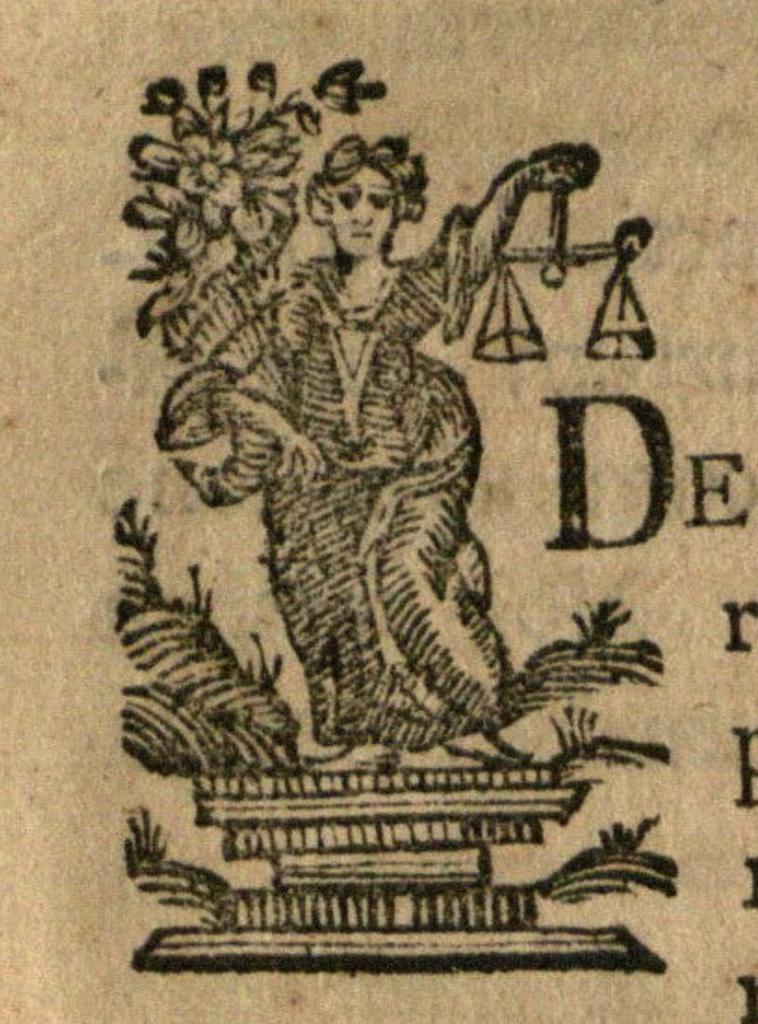<image>
Describe the image concisely. A picture of liberty with her scales and the letters De. 